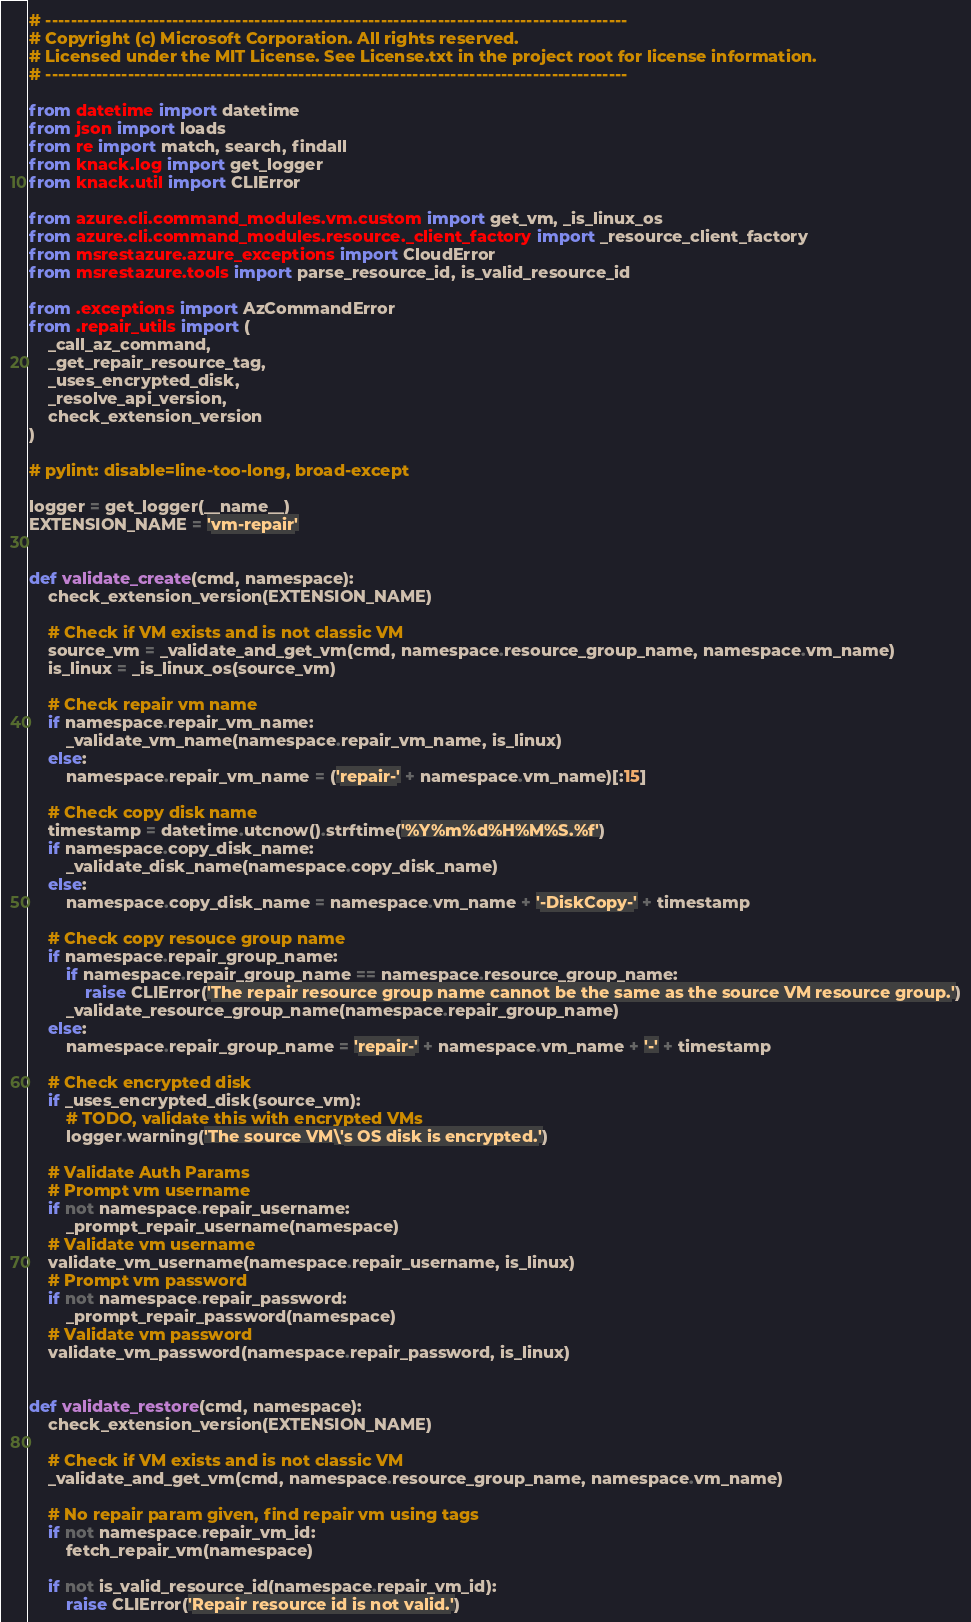Convert code to text. <code><loc_0><loc_0><loc_500><loc_500><_Python_># --------------------------------------------------------------------------------------------
# Copyright (c) Microsoft Corporation. All rights reserved.
# Licensed under the MIT License. See License.txt in the project root for license information.
# --------------------------------------------------------------------------------------------

from datetime import datetime
from json import loads
from re import match, search, findall
from knack.log import get_logger
from knack.util import CLIError

from azure.cli.command_modules.vm.custom import get_vm, _is_linux_os
from azure.cli.command_modules.resource._client_factory import _resource_client_factory
from msrestazure.azure_exceptions import CloudError
from msrestazure.tools import parse_resource_id, is_valid_resource_id

from .exceptions import AzCommandError
from .repair_utils import (
    _call_az_command,
    _get_repair_resource_tag,
    _uses_encrypted_disk,
    _resolve_api_version,
    check_extension_version
)

# pylint: disable=line-too-long, broad-except

logger = get_logger(__name__)
EXTENSION_NAME = 'vm-repair'


def validate_create(cmd, namespace):
    check_extension_version(EXTENSION_NAME)

    # Check if VM exists and is not classic VM
    source_vm = _validate_and_get_vm(cmd, namespace.resource_group_name, namespace.vm_name)
    is_linux = _is_linux_os(source_vm)

    # Check repair vm name
    if namespace.repair_vm_name:
        _validate_vm_name(namespace.repair_vm_name, is_linux)
    else:
        namespace.repair_vm_name = ('repair-' + namespace.vm_name)[:15]

    # Check copy disk name
    timestamp = datetime.utcnow().strftime('%Y%m%d%H%M%S.%f')
    if namespace.copy_disk_name:
        _validate_disk_name(namespace.copy_disk_name)
    else:
        namespace.copy_disk_name = namespace.vm_name + '-DiskCopy-' + timestamp

    # Check copy resouce group name
    if namespace.repair_group_name:
        if namespace.repair_group_name == namespace.resource_group_name:
            raise CLIError('The repair resource group name cannot be the same as the source VM resource group.')
        _validate_resource_group_name(namespace.repair_group_name)
    else:
        namespace.repair_group_name = 'repair-' + namespace.vm_name + '-' + timestamp

    # Check encrypted disk
    if _uses_encrypted_disk(source_vm):
        # TODO, validate this with encrypted VMs
        logger.warning('The source VM\'s OS disk is encrypted.')

    # Validate Auth Params
    # Prompt vm username
    if not namespace.repair_username:
        _prompt_repair_username(namespace)
    # Validate vm username
    validate_vm_username(namespace.repair_username, is_linux)
    # Prompt vm password
    if not namespace.repair_password:
        _prompt_repair_password(namespace)
    # Validate vm password
    validate_vm_password(namespace.repair_password, is_linux)


def validate_restore(cmd, namespace):
    check_extension_version(EXTENSION_NAME)

    # Check if VM exists and is not classic VM
    _validate_and_get_vm(cmd, namespace.resource_group_name, namespace.vm_name)

    # No repair param given, find repair vm using tags
    if not namespace.repair_vm_id:
        fetch_repair_vm(namespace)

    if not is_valid_resource_id(namespace.repair_vm_id):
        raise CLIError('Repair resource id is not valid.')
</code> 